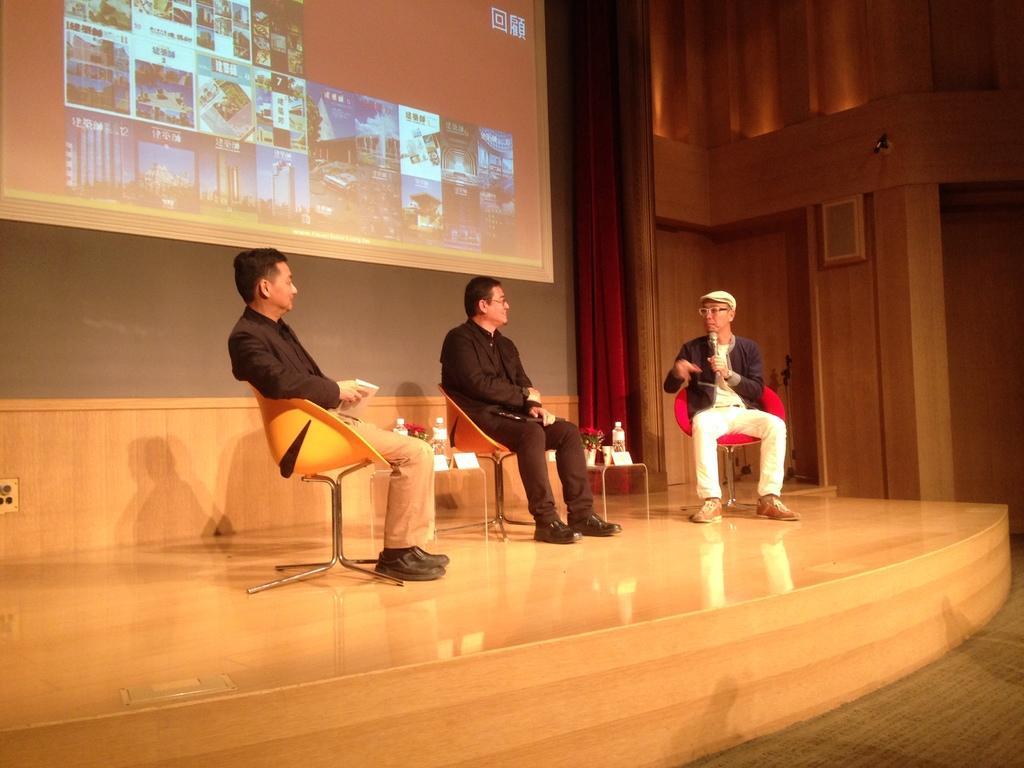Could you give a brief overview of what you see in this image? In this image we can see three persons sitting on the chairs, a person is holding the mic and two of them are holding some objects, there are tables and few objects on the tables, there is a presentation screen and a curtain in the background. 